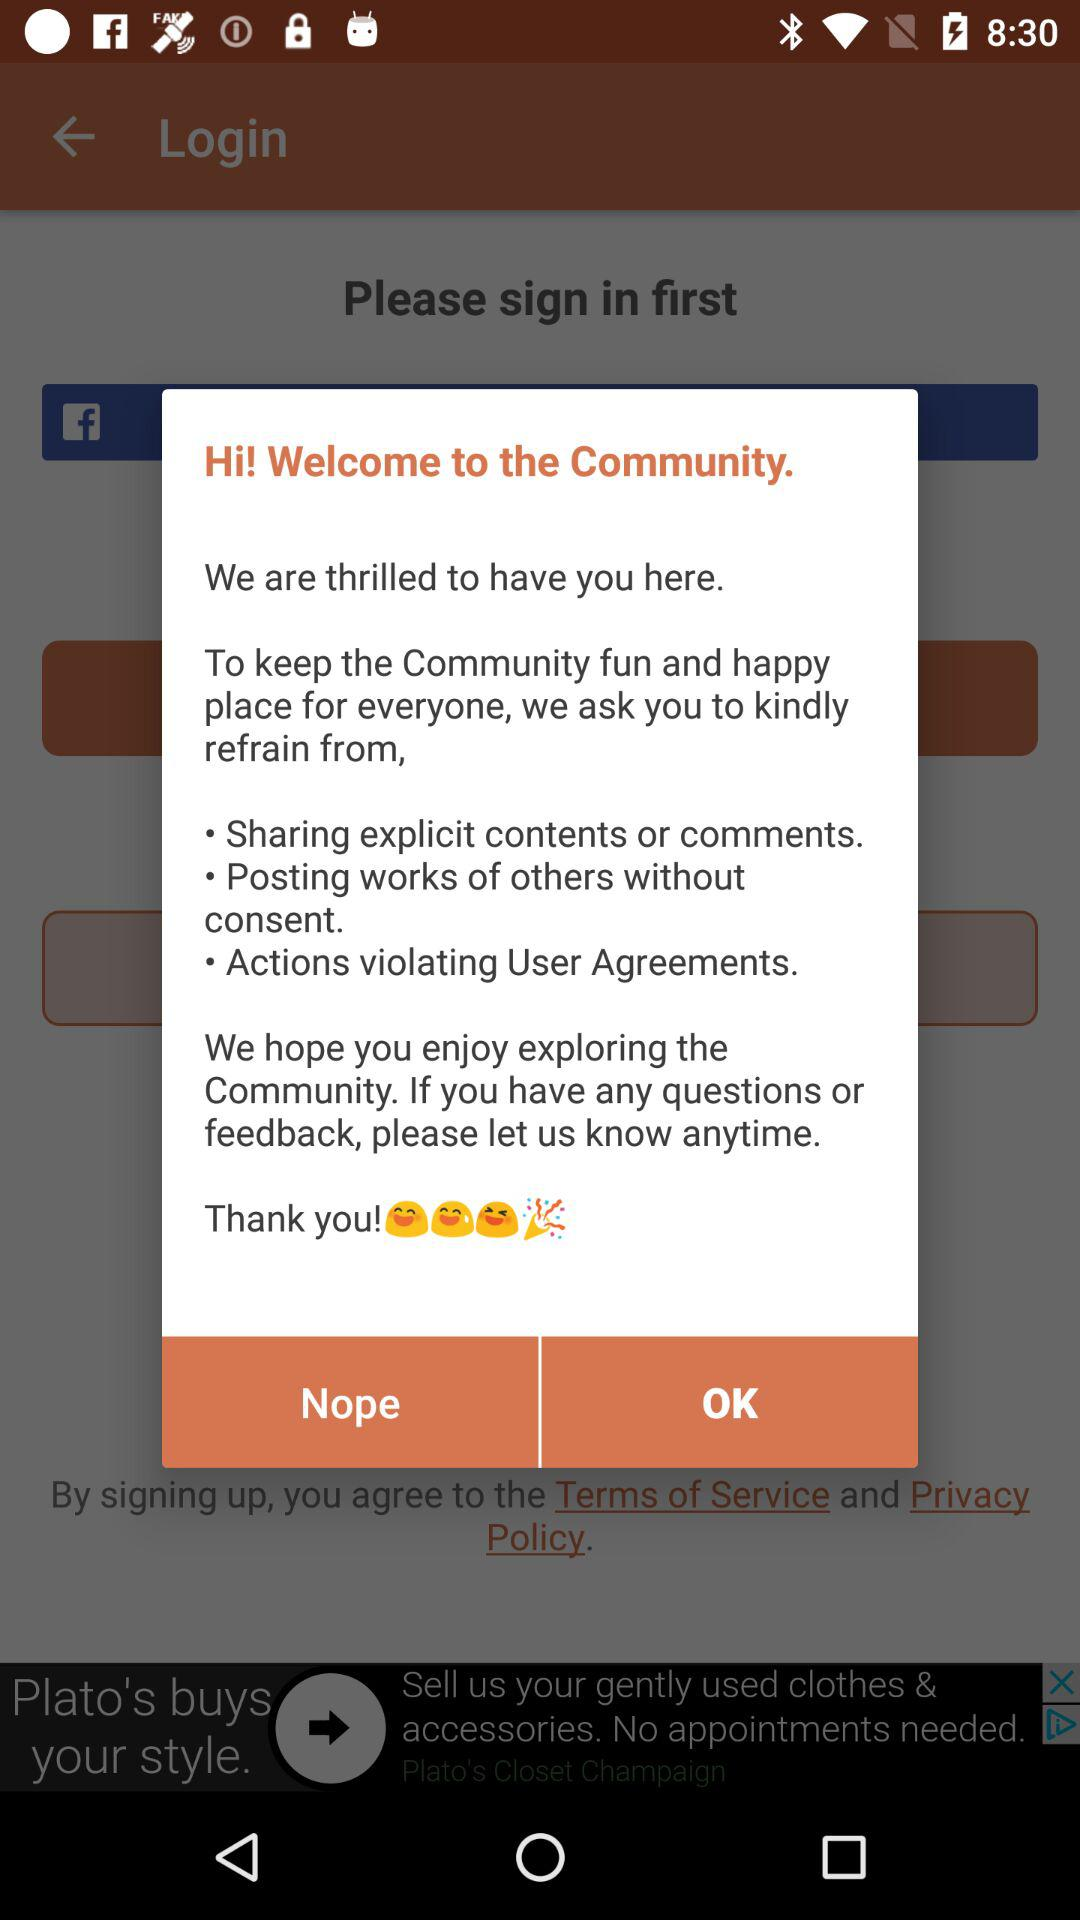How many happy faces are there in the welcome message?
Answer the question using a single word or phrase. 3 